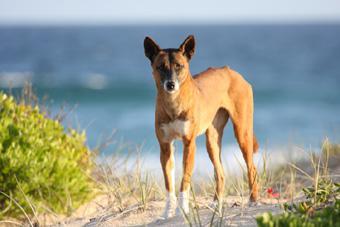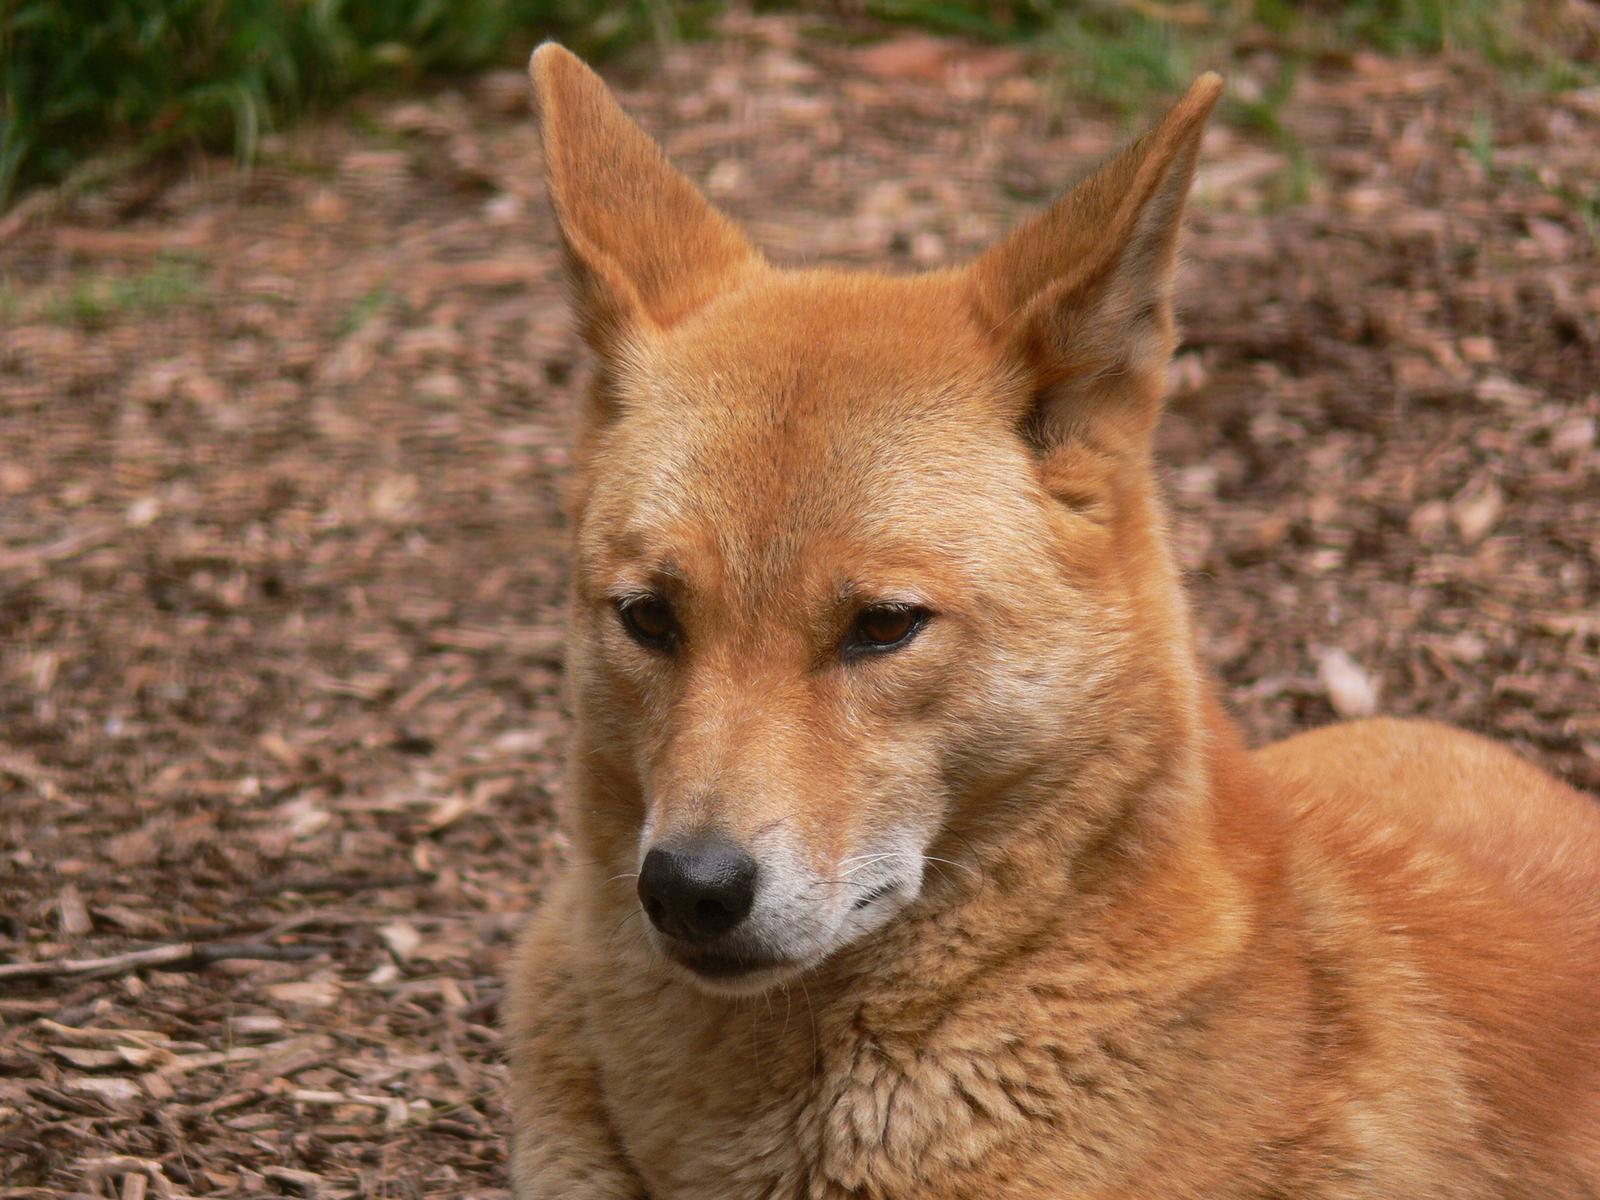The first image is the image on the left, the second image is the image on the right. Analyze the images presented: Is the assertion "A total of two canines are shown." valid? Answer yes or no. Yes. 